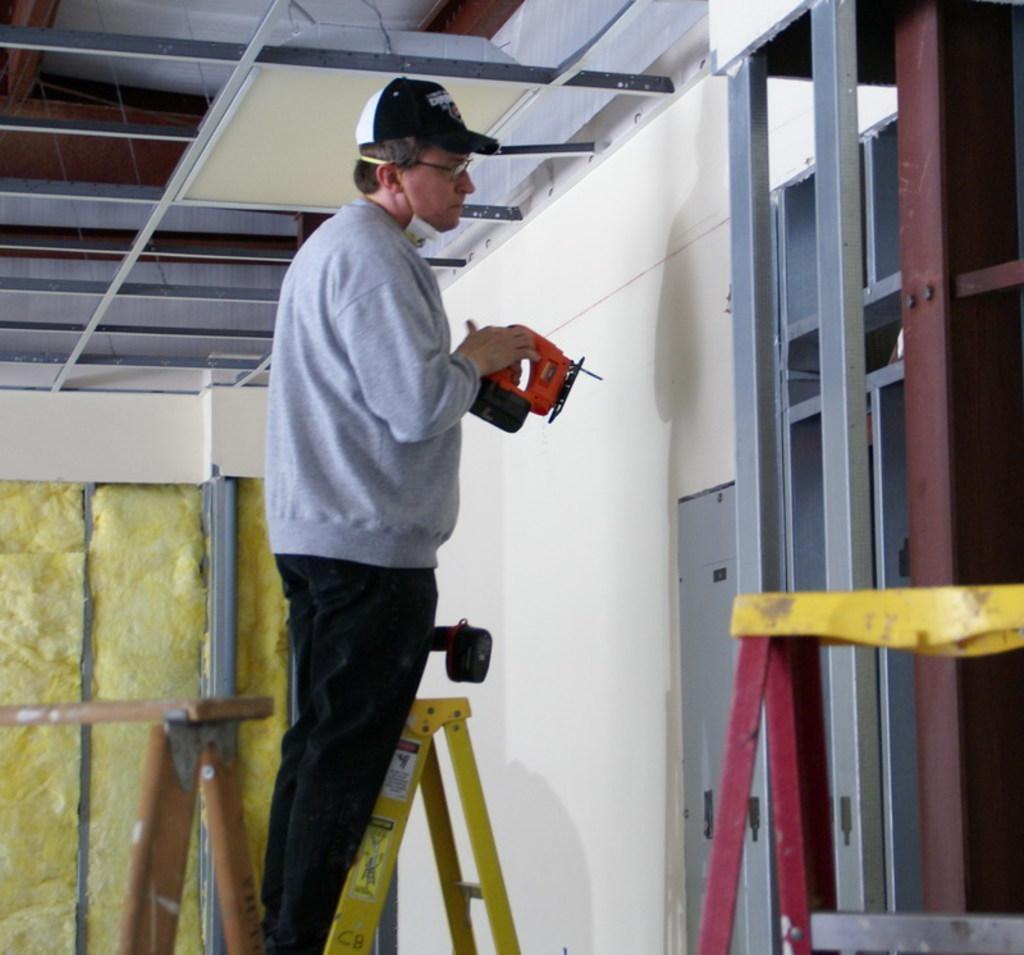Describe this image in one or two sentences. In the image there is a man with cap and spectacles is standing on the ladder and he is holding a machine. In front of him there is a wall with doors. On the right corner of the image there is a ladder and also there are rods. At the top of the image there is ceiling. On the left side of the image there is a wooden object. 